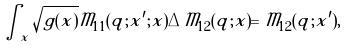<formula> <loc_0><loc_0><loc_500><loc_500>\int _ { \tilde { x } } \sqrt { g ( \tilde { x } ) } \tilde { \mathcal { M } } _ { 1 1 } ( \tilde { q } ; \tilde { x } ^ { \prime } ; \tilde { x } ) \Delta \tilde { \mathcal { M } } _ { 1 2 } ( \tilde { q } ; \tilde { x } ) = \tilde { \mathcal { M } } _ { 1 2 } ( \tilde { q } ; \tilde { x } ^ { \prime } ) ,</formula> 